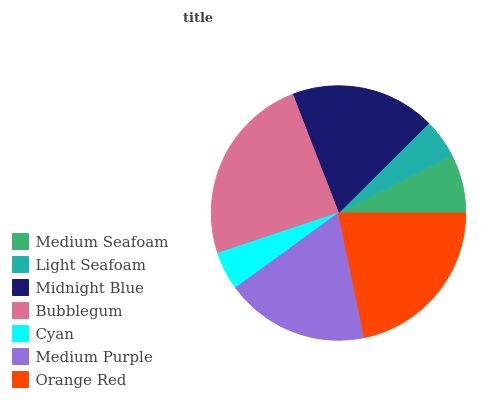Is Cyan the minimum?
Answer yes or no. Yes. Is Bubblegum the maximum?
Answer yes or no. Yes. Is Light Seafoam the minimum?
Answer yes or no. No. Is Light Seafoam the maximum?
Answer yes or no. No. Is Medium Seafoam greater than Light Seafoam?
Answer yes or no. Yes. Is Light Seafoam less than Medium Seafoam?
Answer yes or no. Yes. Is Light Seafoam greater than Medium Seafoam?
Answer yes or no. No. Is Medium Seafoam less than Light Seafoam?
Answer yes or no. No. Is Medium Purple the high median?
Answer yes or no. Yes. Is Medium Purple the low median?
Answer yes or no. Yes. Is Cyan the high median?
Answer yes or no. No. Is Midnight Blue the low median?
Answer yes or no. No. 